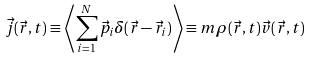Convert formula to latex. <formula><loc_0><loc_0><loc_500><loc_500>\vec { j } ( \vec { r } , t ) \equiv \left \langle \sum _ { i = 1 } ^ { N } \vec { p } _ { i } \delta ( \vec { r } - \vec { r } _ { i } ) \right \rangle \equiv m \rho ( \vec { r } , t ) \vec { v } ( \vec { r } , t )</formula> 